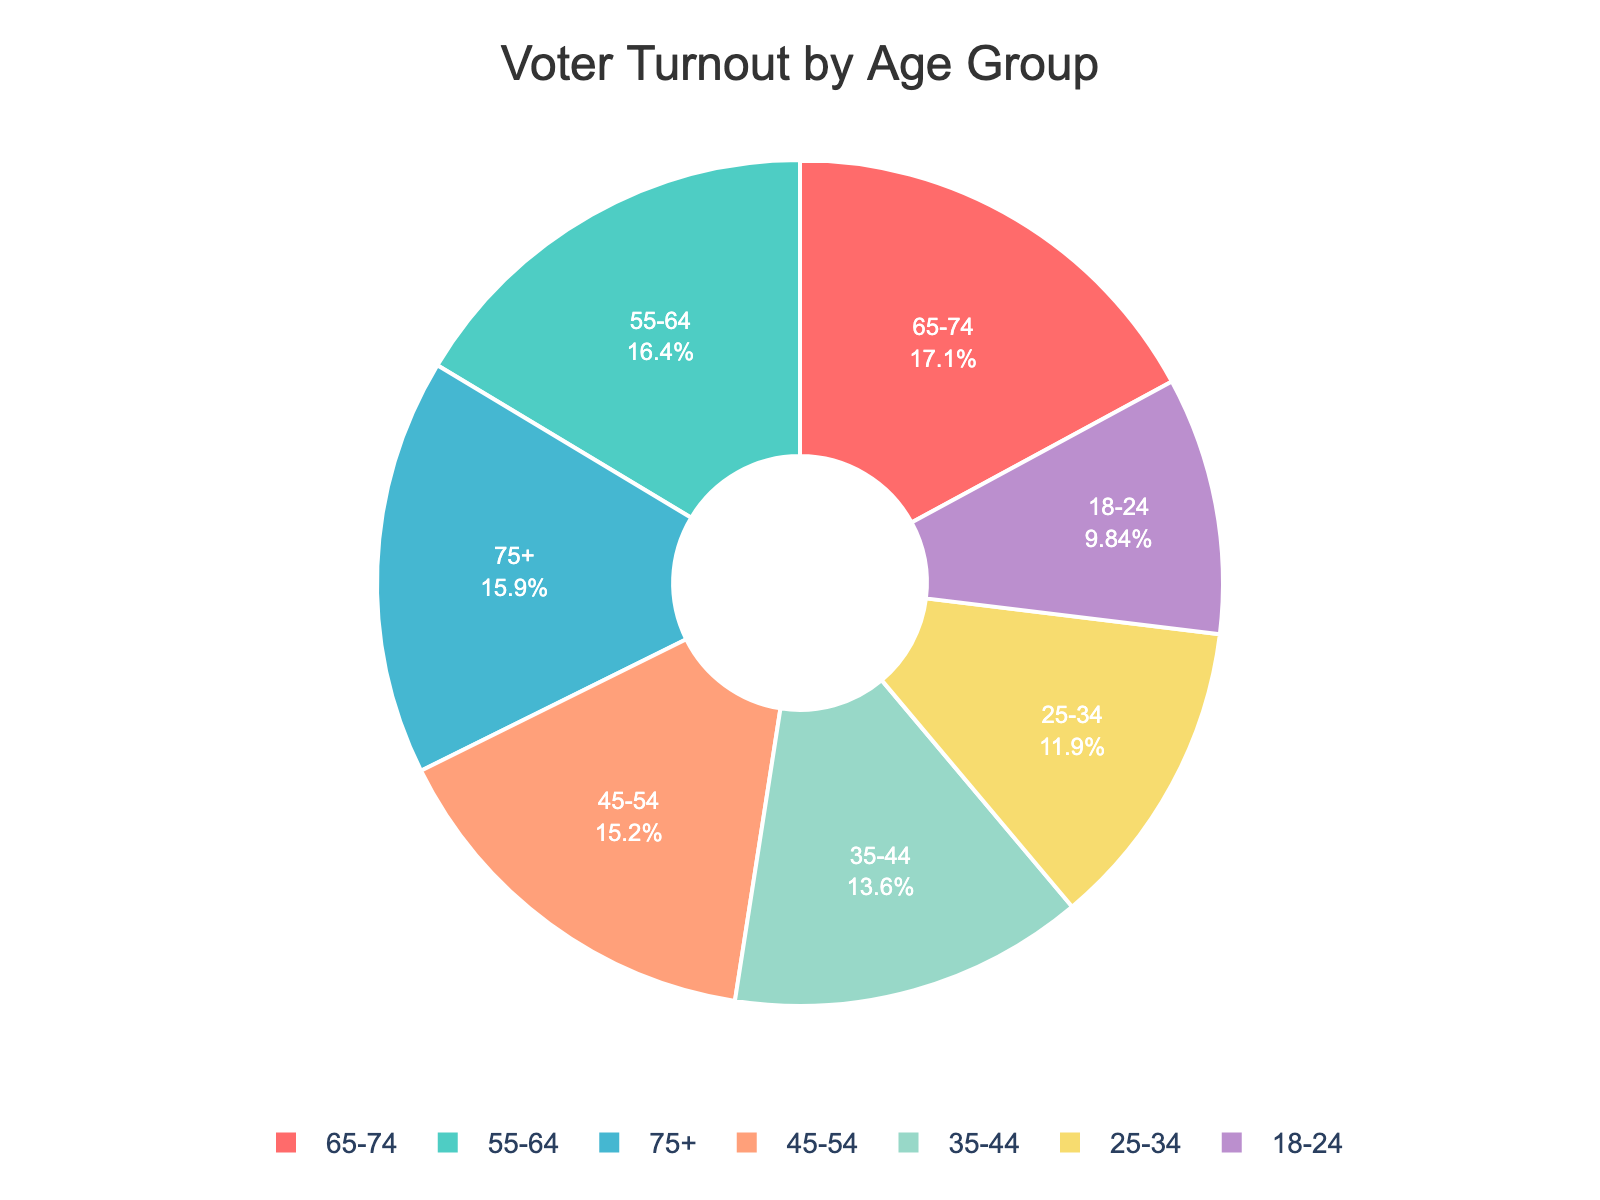What's the age group with the lowest voter turnout percentage? Simply by looking at the pie chart, identify the slice representing the smallest voter turnout percentage.
Answer: 18-24 Which age group has the highest voter turnout percentage? By observing the chart, pick the slice corresponding to the highest voter turnout percentage.
Answer: 65-74 What is the difference in voter turnout percentage between the 25-34 and the 55-64 age groups? Locate the percentages for 25-34 and 55-64 from the pie chart, then subtract the smaller percentage from the larger one: 70 - 51 = 19.
Answer: 19 How does the voter turnout percentage of the 75+ age group compare to the 45-54 age group? Identify the percentages for both age groups and compare them: 75+ has 68% and 45-54 has 65%. 68% is greater than 65% by 3%.
Answer: 3% What is the combined voter turnout percentage for the age groups 18-24 and 25-34? Add the percentages for the two age groups together: 42% + 51% = 93%.
Answer: 93% Which slices of the pie chart represent voter turnout percentages above 60%? Identify all slices with a percentage greater than 60%. The age groups are 55-64 (70%), 65-74 (73%), and 75+ (68%).
Answer: 55-64, 65-74, 75+ What is the average voter turnout percentage for the age groups under 35 (18-24 and 25-34)? Sum the percentages for 18-24 and 25-34, then divide by the number of age groups: (42 + 51) / 2 = 46.5%.
Answer: 46.5% How many age groups have a voter turnout percentage higher than 65%? Count the slices with a percentage more than 65%. The age groups are 65-74 (73%) and 55-64 (70%), so there are two groups.
Answer: 2 